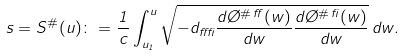<formula> <loc_0><loc_0><loc_500><loc_500>s = S ^ { \# } ( u ) \colon = \frac { 1 } { c } \int _ { u _ { 1 } } ^ { u } \sqrt { - d _ { \alpha \beta } \frac { d \chi ^ { \# \, \alpha } ( w ) } { d w } \frac { d \chi ^ { \# \, \beta } ( w ) } { d w } } \, d w .</formula> 